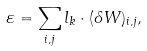<formula> <loc_0><loc_0><loc_500><loc_500>\varepsilon = \sum _ { i , j } l _ { k } \cdot ( \delta W ) _ { i , j } ,</formula> 